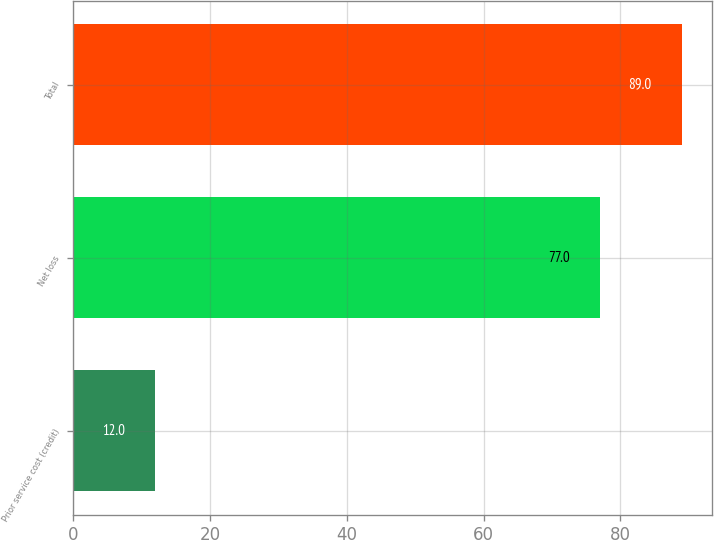Convert chart to OTSL. <chart><loc_0><loc_0><loc_500><loc_500><bar_chart><fcel>Prior service cost (credit)<fcel>Net loss<fcel>Total<nl><fcel>12<fcel>77<fcel>89<nl></chart> 